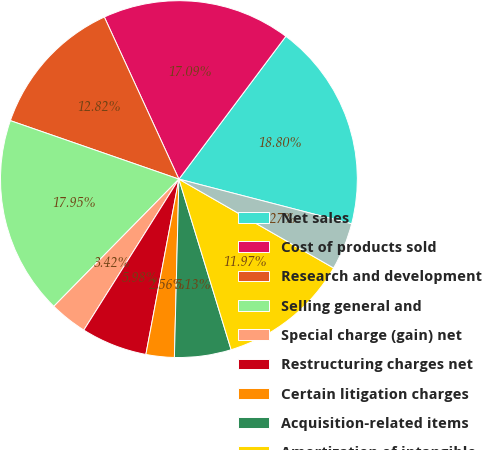Convert chart to OTSL. <chart><loc_0><loc_0><loc_500><loc_500><pie_chart><fcel>Net sales<fcel>Cost of products sold<fcel>Research and development<fcel>Selling general and<fcel>Special charge (gain) net<fcel>Restructuring charges net<fcel>Certain litigation charges<fcel>Acquisition-related items<fcel>Amortization of intangible<fcel>Other expense net<nl><fcel>18.8%<fcel>17.09%<fcel>12.82%<fcel>17.95%<fcel>3.42%<fcel>5.98%<fcel>2.56%<fcel>5.13%<fcel>11.97%<fcel>4.27%<nl></chart> 